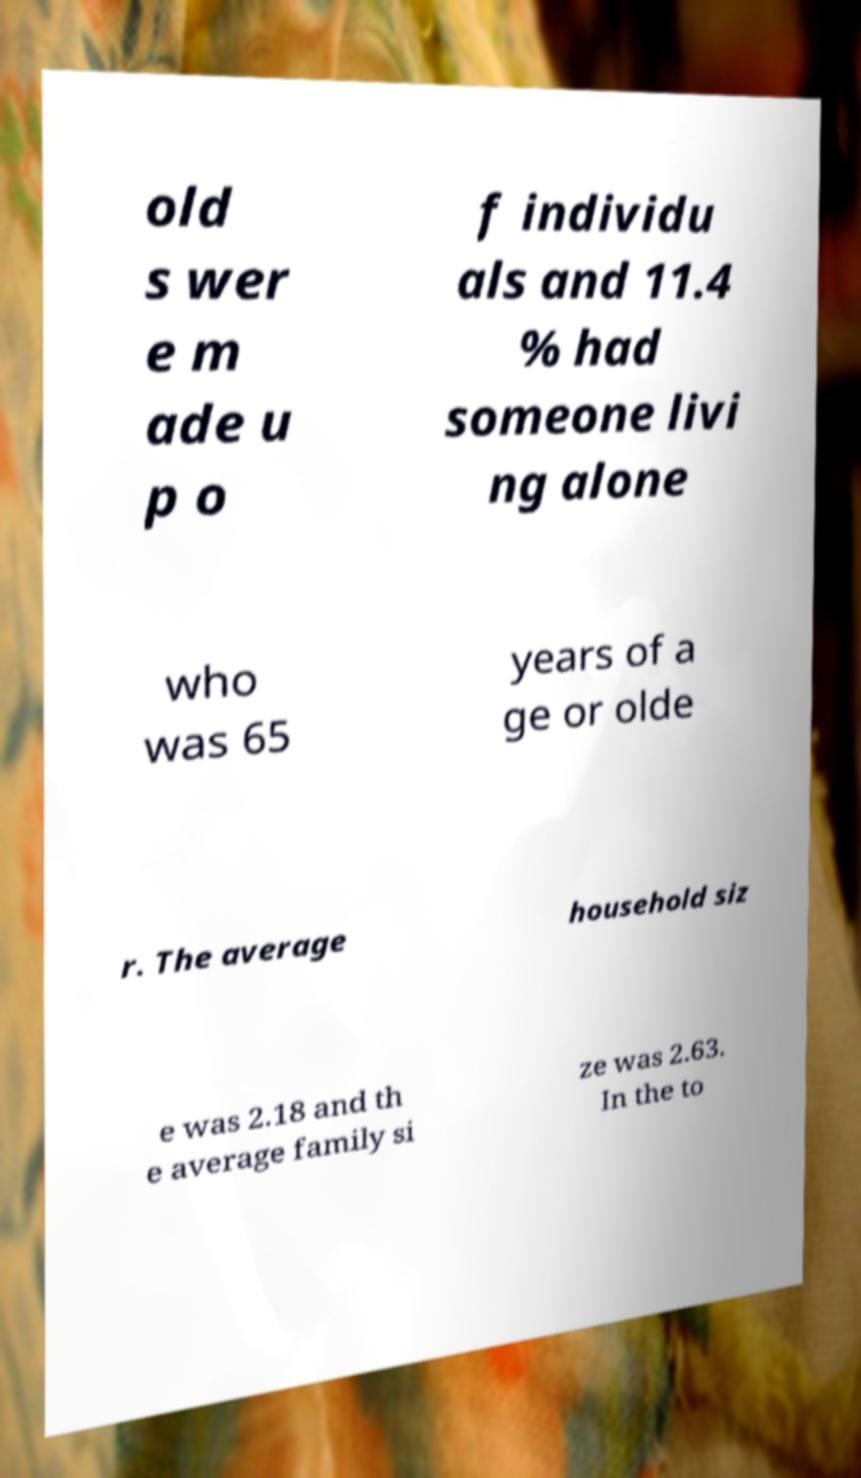Please read and relay the text visible in this image. What does it say? old s wer e m ade u p o f individu als and 11.4 % had someone livi ng alone who was 65 years of a ge or olde r. The average household siz e was 2.18 and th e average family si ze was 2.63. In the to 